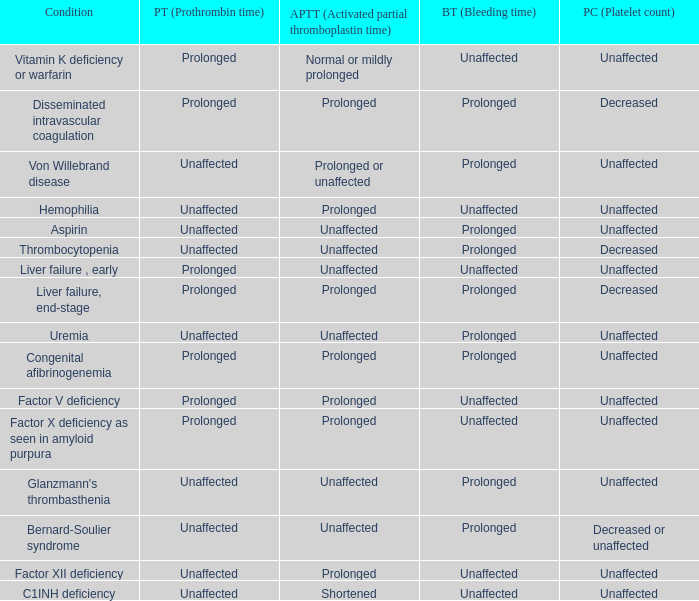Which Condition has an unaffected Partial thromboplastin time, Platelet count, and a Prothrombin time? Aspirin, Uremia, Glanzmann's thrombasthenia. 